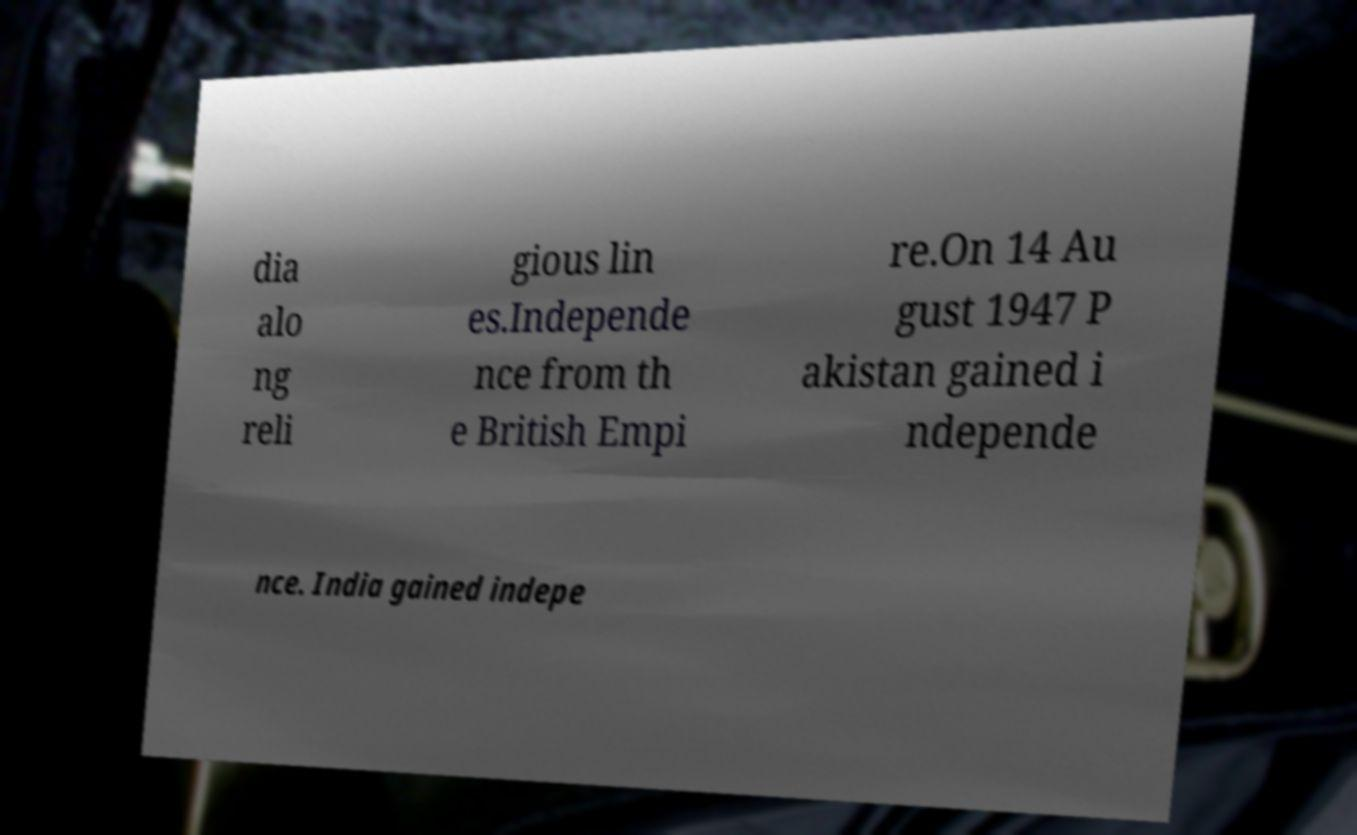Can you accurately transcribe the text from the provided image for me? dia alo ng reli gious lin es.Independe nce from th e British Empi re.On 14 Au gust 1947 P akistan gained i ndepende nce. India gained indepe 